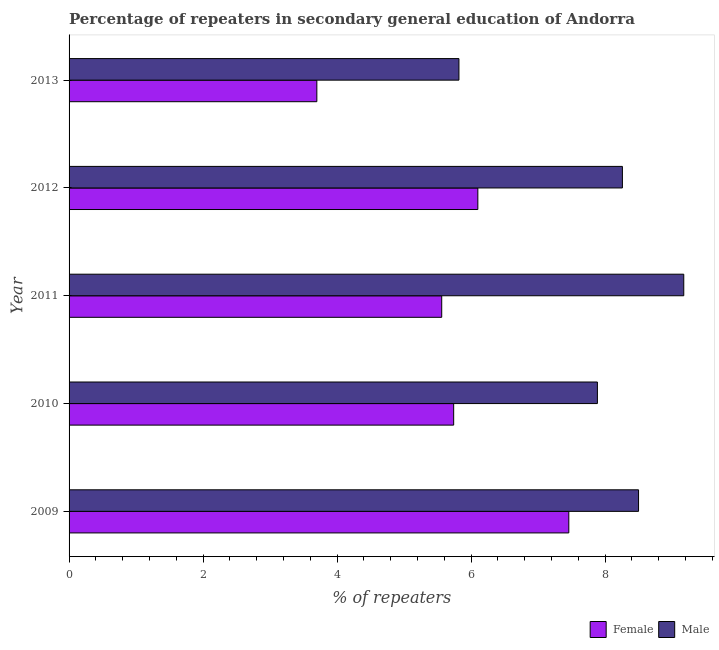Are the number of bars per tick equal to the number of legend labels?
Keep it short and to the point. Yes. Are the number of bars on each tick of the Y-axis equal?
Make the answer very short. Yes. How many bars are there on the 5th tick from the top?
Keep it short and to the point. 2. What is the percentage of female repeaters in 2011?
Make the answer very short. 5.56. Across all years, what is the maximum percentage of female repeaters?
Give a very brief answer. 7.46. Across all years, what is the minimum percentage of female repeaters?
Provide a succinct answer. 3.7. In which year was the percentage of male repeaters maximum?
Give a very brief answer. 2011. In which year was the percentage of female repeaters minimum?
Provide a short and direct response. 2013. What is the total percentage of male repeaters in the graph?
Your answer should be compact. 39.63. What is the difference between the percentage of female repeaters in 2009 and that in 2012?
Your answer should be very brief. 1.36. What is the difference between the percentage of female repeaters in 2010 and the percentage of male repeaters in 2009?
Ensure brevity in your answer.  -2.76. What is the average percentage of male repeaters per year?
Give a very brief answer. 7.93. In the year 2011, what is the difference between the percentage of female repeaters and percentage of male repeaters?
Ensure brevity in your answer.  -3.61. What is the ratio of the percentage of female repeaters in 2011 to that in 2012?
Your response must be concise. 0.91. Is the percentage of male repeaters in 2009 less than that in 2012?
Provide a succinct answer. No. What is the difference between the highest and the second highest percentage of female repeaters?
Offer a terse response. 1.36. What is the difference between the highest and the lowest percentage of male repeaters?
Ensure brevity in your answer.  3.36. In how many years, is the percentage of female repeaters greater than the average percentage of female repeaters taken over all years?
Keep it short and to the point. 3. Is the sum of the percentage of male repeaters in 2009 and 2012 greater than the maximum percentage of female repeaters across all years?
Provide a short and direct response. Yes. What does the 2nd bar from the top in 2013 represents?
Give a very brief answer. Female. How many bars are there?
Ensure brevity in your answer.  10. What is the difference between two consecutive major ticks on the X-axis?
Give a very brief answer. 2. Does the graph contain any zero values?
Make the answer very short. No. Does the graph contain grids?
Ensure brevity in your answer.  No. How many legend labels are there?
Your answer should be very brief. 2. What is the title of the graph?
Your answer should be very brief. Percentage of repeaters in secondary general education of Andorra. Does "Forest" appear as one of the legend labels in the graph?
Provide a succinct answer. No. What is the label or title of the X-axis?
Offer a very short reply. % of repeaters. What is the % of repeaters in Female in 2009?
Make the answer very short. 7.46. What is the % of repeaters in Male in 2009?
Your answer should be very brief. 8.5. What is the % of repeaters of Female in 2010?
Your answer should be very brief. 5.74. What is the % of repeaters of Male in 2010?
Offer a terse response. 7.89. What is the % of repeaters in Female in 2011?
Keep it short and to the point. 5.56. What is the % of repeaters of Male in 2011?
Offer a very short reply. 9.17. What is the % of repeaters of Female in 2012?
Your answer should be very brief. 6.1. What is the % of repeaters of Male in 2012?
Ensure brevity in your answer.  8.26. What is the % of repeaters of Female in 2013?
Ensure brevity in your answer.  3.7. What is the % of repeaters of Male in 2013?
Your answer should be compact. 5.82. Across all years, what is the maximum % of repeaters of Female?
Offer a very short reply. 7.46. Across all years, what is the maximum % of repeaters in Male?
Your answer should be very brief. 9.17. Across all years, what is the minimum % of repeaters of Female?
Provide a short and direct response. 3.7. Across all years, what is the minimum % of repeaters in Male?
Your response must be concise. 5.82. What is the total % of repeaters of Female in the graph?
Ensure brevity in your answer.  28.56. What is the total % of repeaters in Male in the graph?
Give a very brief answer. 39.63. What is the difference between the % of repeaters in Female in 2009 and that in 2010?
Offer a very short reply. 1.72. What is the difference between the % of repeaters of Male in 2009 and that in 2010?
Keep it short and to the point. 0.61. What is the difference between the % of repeaters in Female in 2009 and that in 2011?
Make the answer very short. 1.9. What is the difference between the % of repeaters of Male in 2009 and that in 2011?
Your answer should be compact. -0.67. What is the difference between the % of repeaters in Female in 2009 and that in 2012?
Your answer should be very brief. 1.36. What is the difference between the % of repeaters in Male in 2009 and that in 2012?
Provide a succinct answer. 0.24. What is the difference between the % of repeaters in Female in 2009 and that in 2013?
Provide a short and direct response. 3.76. What is the difference between the % of repeaters of Male in 2009 and that in 2013?
Your response must be concise. 2.68. What is the difference between the % of repeaters of Female in 2010 and that in 2011?
Give a very brief answer. 0.18. What is the difference between the % of repeaters of Male in 2010 and that in 2011?
Offer a terse response. -1.29. What is the difference between the % of repeaters of Female in 2010 and that in 2012?
Provide a succinct answer. -0.36. What is the difference between the % of repeaters in Male in 2010 and that in 2012?
Make the answer very short. -0.37. What is the difference between the % of repeaters of Female in 2010 and that in 2013?
Ensure brevity in your answer.  2.04. What is the difference between the % of repeaters of Male in 2010 and that in 2013?
Give a very brief answer. 2.07. What is the difference between the % of repeaters of Female in 2011 and that in 2012?
Provide a short and direct response. -0.54. What is the difference between the % of repeaters of Male in 2011 and that in 2012?
Give a very brief answer. 0.92. What is the difference between the % of repeaters of Female in 2011 and that in 2013?
Your answer should be very brief. 1.86. What is the difference between the % of repeaters in Male in 2011 and that in 2013?
Make the answer very short. 3.36. What is the difference between the % of repeaters of Female in 2012 and that in 2013?
Make the answer very short. 2.4. What is the difference between the % of repeaters in Male in 2012 and that in 2013?
Your answer should be very brief. 2.44. What is the difference between the % of repeaters in Female in 2009 and the % of repeaters in Male in 2010?
Make the answer very short. -0.43. What is the difference between the % of repeaters in Female in 2009 and the % of repeaters in Male in 2011?
Offer a terse response. -1.72. What is the difference between the % of repeaters in Female in 2009 and the % of repeaters in Male in 2012?
Offer a terse response. -0.8. What is the difference between the % of repeaters of Female in 2009 and the % of repeaters of Male in 2013?
Offer a terse response. 1.64. What is the difference between the % of repeaters in Female in 2010 and the % of repeaters in Male in 2011?
Keep it short and to the point. -3.43. What is the difference between the % of repeaters of Female in 2010 and the % of repeaters of Male in 2012?
Your answer should be very brief. -2.52. What is the difference between the % of repeaters in Female in 2010 and the % of repeaters in Male in 2013?
Ensure brevity in your answer.  -0.08. What is the difference between the % of repeaters of Female in 2011 and the % of repeaters of Male in 2012?
Keep it short and to the point. -2.7. What is the difference between the % of repeaters of Female in 2011 and the % of repeaters of Male in 2013?
Your answer should be very brief. -0.26. What is the difference between the % of repeaters of Female in 2012 and the % of repeaters of Male in 2013?
Your answer should be very brief. 0.28. What is the average % of repeaters of Female per year?
Your response must be concise. 5.71. What is the average % of repeaters of Male per year?
Your answer should be compact. 7.93. In the year 2009, what is the difference between the % of repeaters in Female and % of repeaters in Male?
Your response must be concise. -1.04. In the year 2010, what is the difference between the % of repeaters in Female and % of repeaters in Male?
Your answer should be very brief. -2.15. In the year 2011, what is the difference between the % of repeaters in Female and % of repeaters in Male?
Offer a very short reply. -3.61. In the year 2012, what is the difference between the % of repeaters in Female and % of repeaters in Male?
Offer a terse response. -2.16. In the year 2013, what is the difference between the % of repeaters in Female and % of repeaters in Male?
Your response must be concise. -2.12. What is the ratio of the % of repeaters in Female in 2009 to that in 2010?
Ensure brevity in your answer.  1.3. What is the ratio of the % of repeaters in Male in 2009 to that in 2010?
Keep it short and to the point. 1.08. What is the ratio of the % of repeaters in Female in 2009 to that in 2011?
Your answer should be compact. 1.34. What is the ratio of the % of repeaters in Male in 2009 to that in 2011?
Give a very brief answer. 0.93. What is the ratio of the % of repeaters in Female in 2009 to that in 2012?
Provide a succinct answer. 1.22. What is the ratio of the % of repeaters of Male in 2009 to that in 2012?
Your response must be concise. 1.03. What is the ratio of the % of repeaters of Female in 2009 to that in 2013?
Your answer should be very brief. 2.02. What is the ratio of the % of repeaters in Male in 2009 to that in 2013?
Provide a short and direct response. 1.46. What is the ratio of the % of repeaters in Female in 2010 to that in 2011?
Provide a succinct answer. 1.03. What is the ratio of the % of repeaters in Male in 2010 to that in 2011?
Ensure brevity in your answer.  0.86. What is the ratio of the % of repeaters of Female in 2010 to that in 2012?
Offer a very short reply. 0.94. What is the ratio of the % of repeaters in Male in 2010 to that in 2012?
Your answer should be compact. 0.95. What is the ratio of the % of repeaters in Female in 2010 to that in 2013?
Provide a succinct answer. 1.55. What is the ratio of the % of repeaters in Male in 2010 to that in 2013?
Your answer should be compact. 1.36. What is the ratio of the % of repeaters of Female in 2011 to that in 2012?
Offer a terse response. 0.91. What is the ratio of the % of repeaters in Male in 2011 to that in 2012?
Your answer should be very brief. 1.11. What is the ratio of the % of repeaters in Female in 2011 to that in 2013?
Your answer should be very brief. 1.5. What is the ratio of the % of repeaters in Male in 2011 to that in 2013?
Your response must be concise. 1.58. What is the ratio of the % of repeaters of Female in 2012 to that in 2013?
Offer a terse response. 1.65. What is the ratio of the % of repeaters of Male in 2012 to that in 2013?
Your answer should be compact. 1.42. What is the difference between the highest and the second highest % of repeaters in Female?
Offer a terse response. 1.36. What is the difference between the highest and the second highest % of repeaters in Male?
Your response must be concise. 0.67. What is the difference between the highest and the lowest % of repeaters of Female?
Your answer should be compact. 3.76. What is the difference between the highest and the lowest % of repeaters of Male?
Keep it short and to the point. 3.36. 